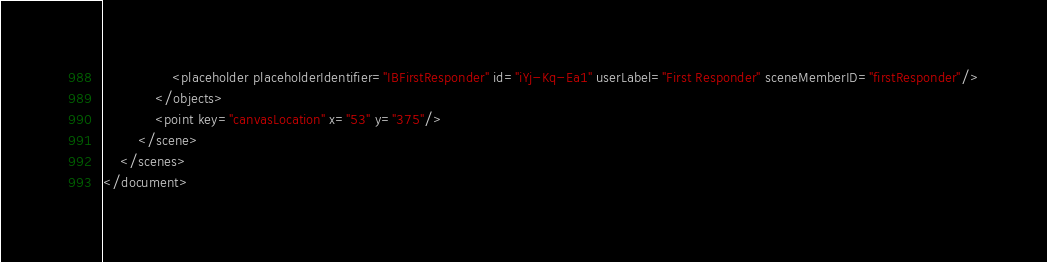Convert code to text. <code><loc_0><loc_0><loc_500><loc_500><_XML_>                <placeholder placeholderIdentifier="IBFirstResponder" id="iYj-Kq-Ea1" userLabel="First Responder" sceneMemberID="firstResponder"/>
            </objects>
            <point key="canvasLocation" x="53" y="375"/>
        </scene>
    </scenes>
</document>
</code> 